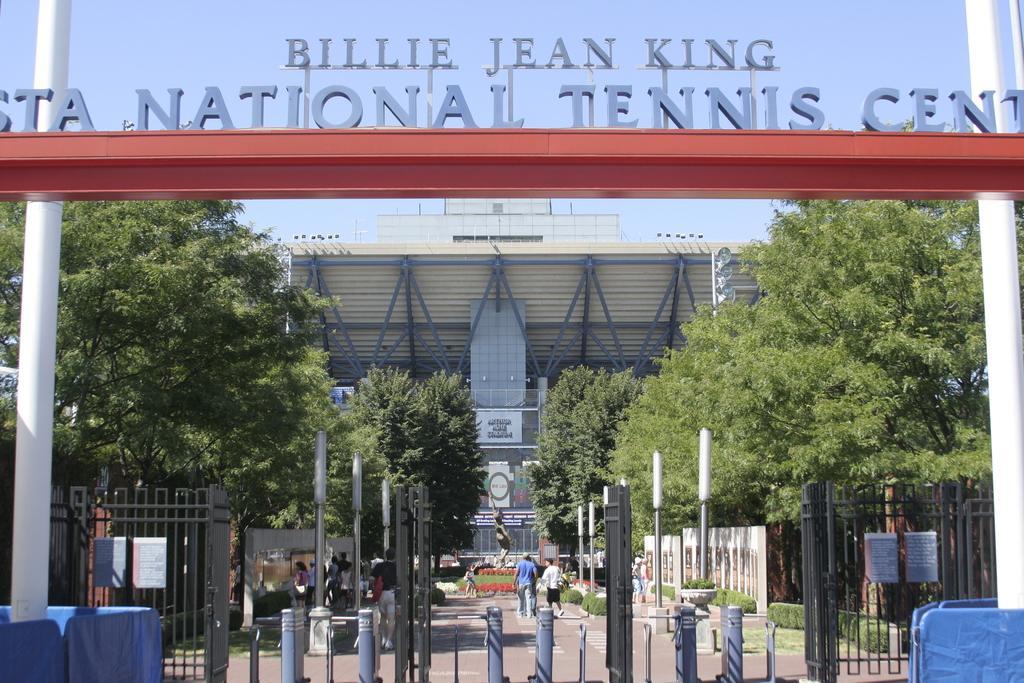Can you describe this image briefly? There is text on entrance and poles in the foreground area of the image, there are people, trees, it seems like a boundary, gate, building and the sky in the background. 